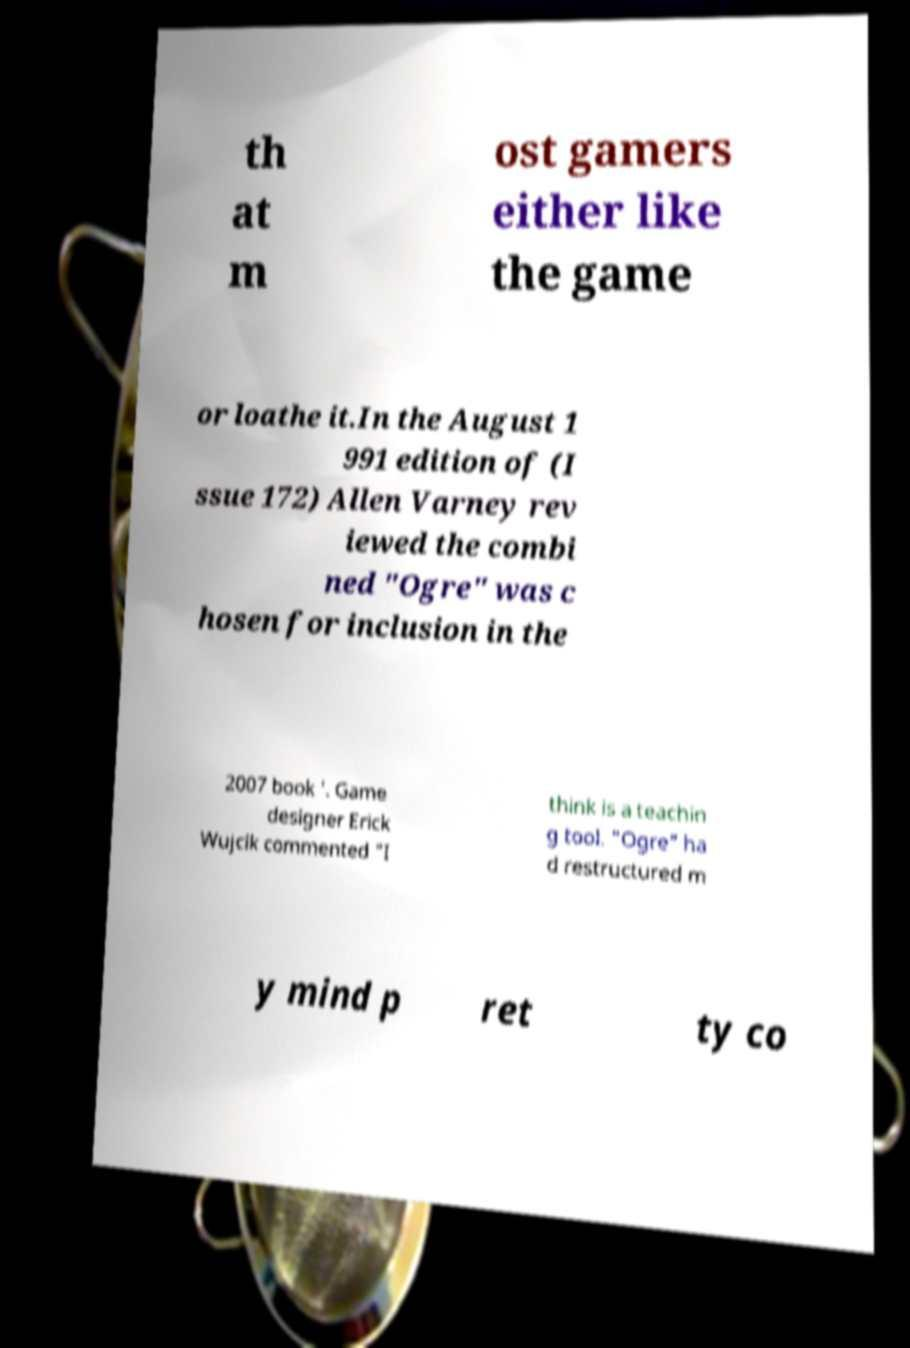Please identify and transcribe the text found in this image. th at m ost gamers either like the game or loathe it.In the August 1 991 edition of (I ssue 172) Allen Varney rev iewed the combi ned "Ogre" was c hosen for inclusion in the 2007 book '. Game designer Erick Wujcik commented "I think is a teachin g tool. "Ogre" ha d restructured m y mind p ret ty co 